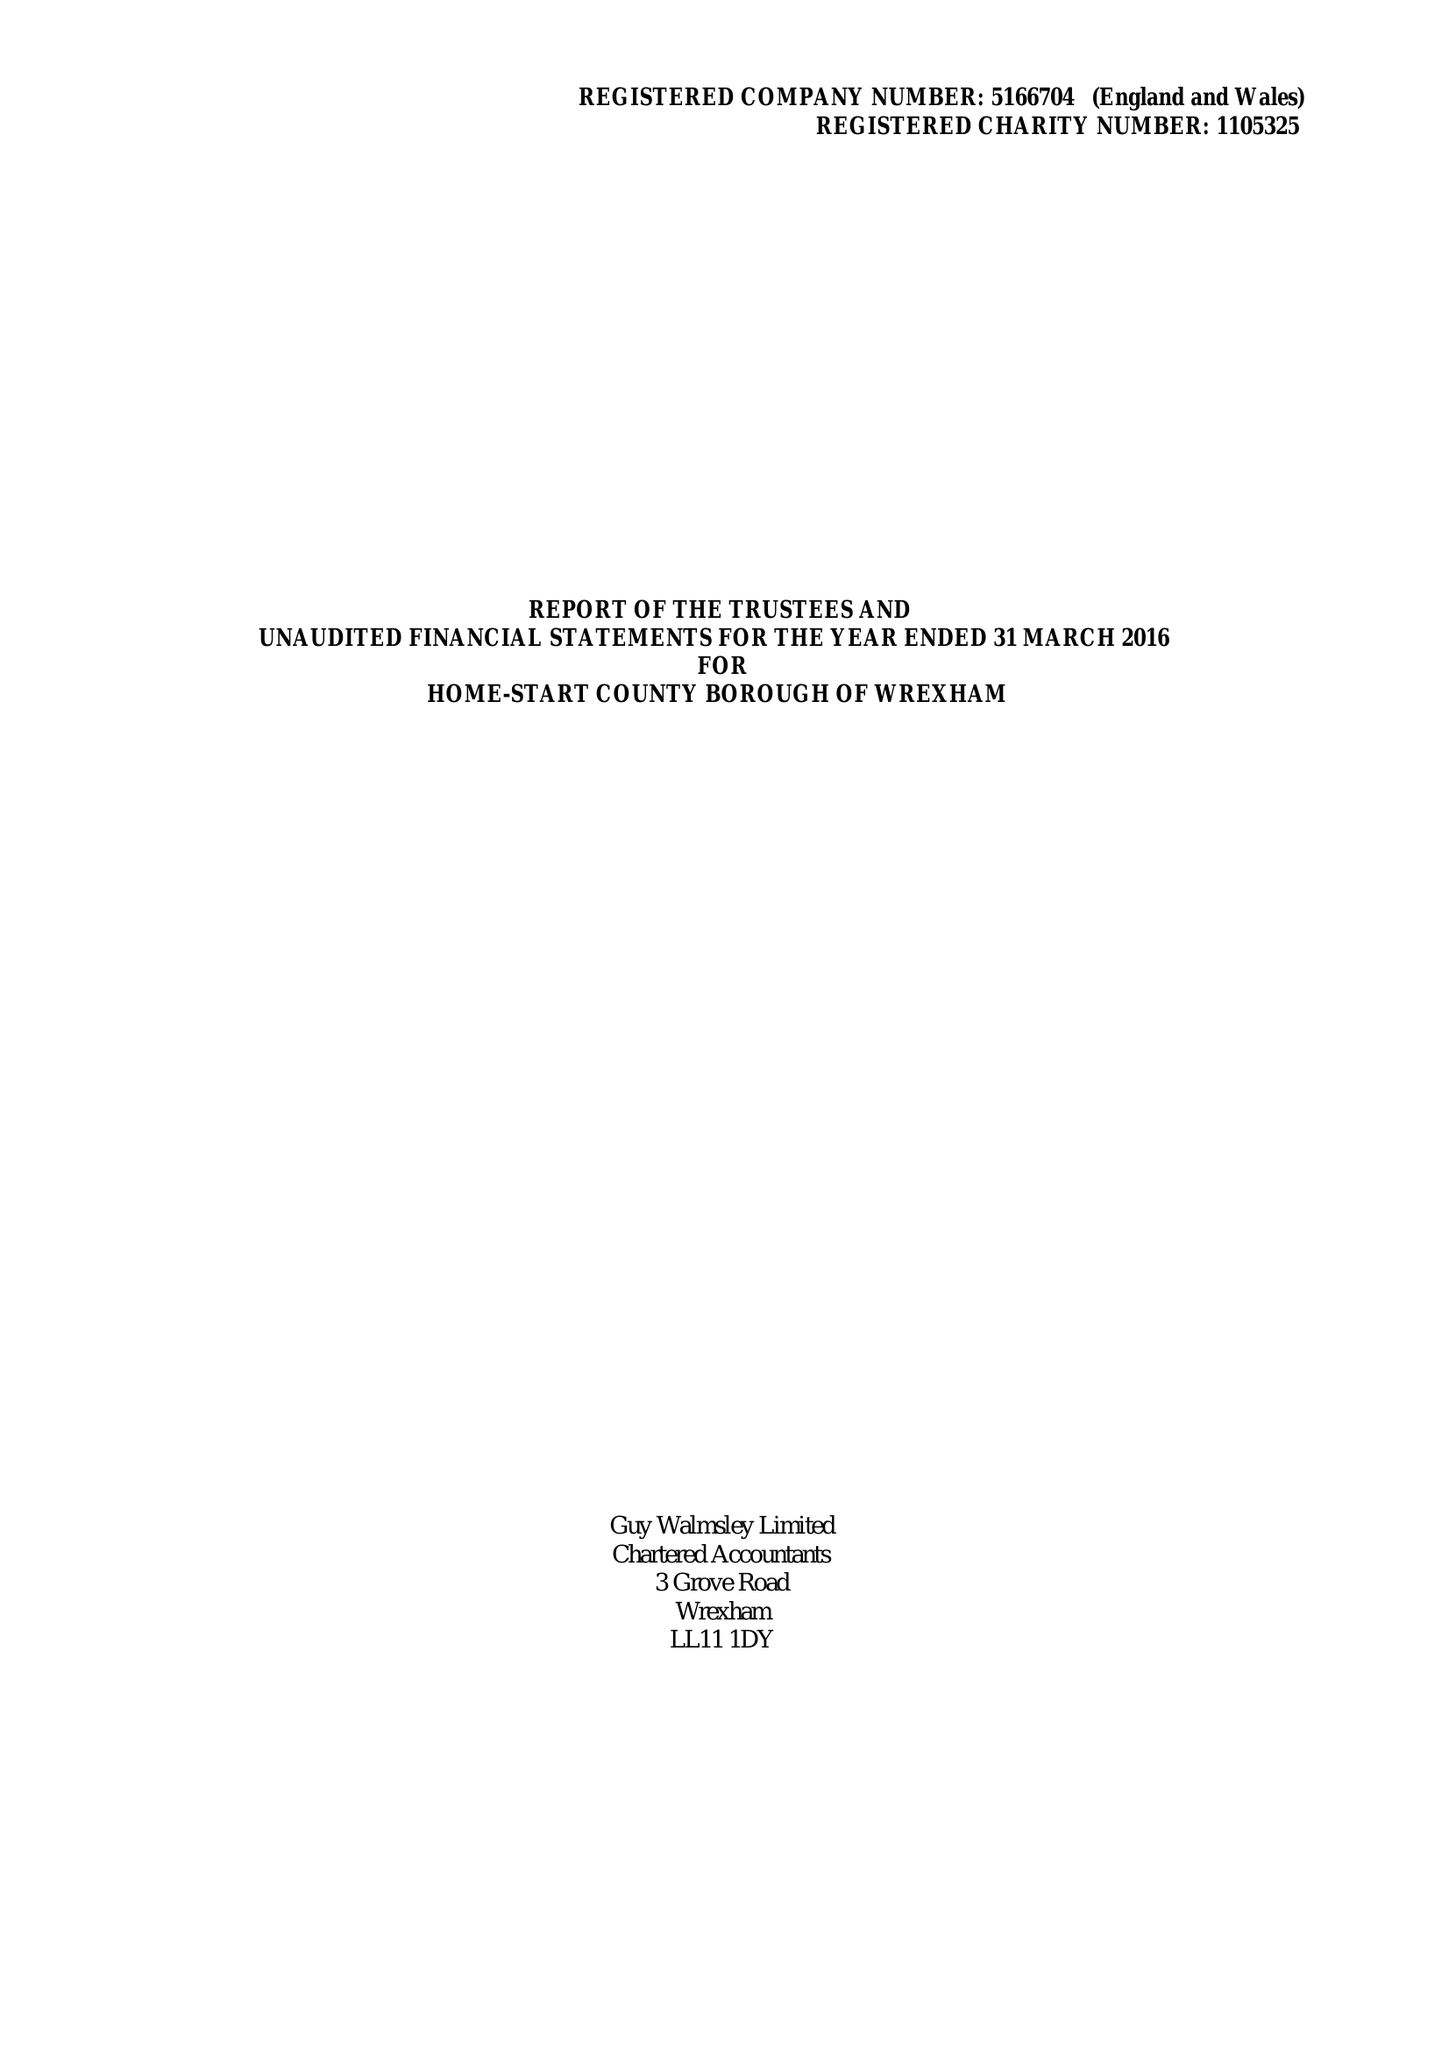What is the value for the address__street_line?
Answer the question using a single word or phrase. GARDEN ROAD 